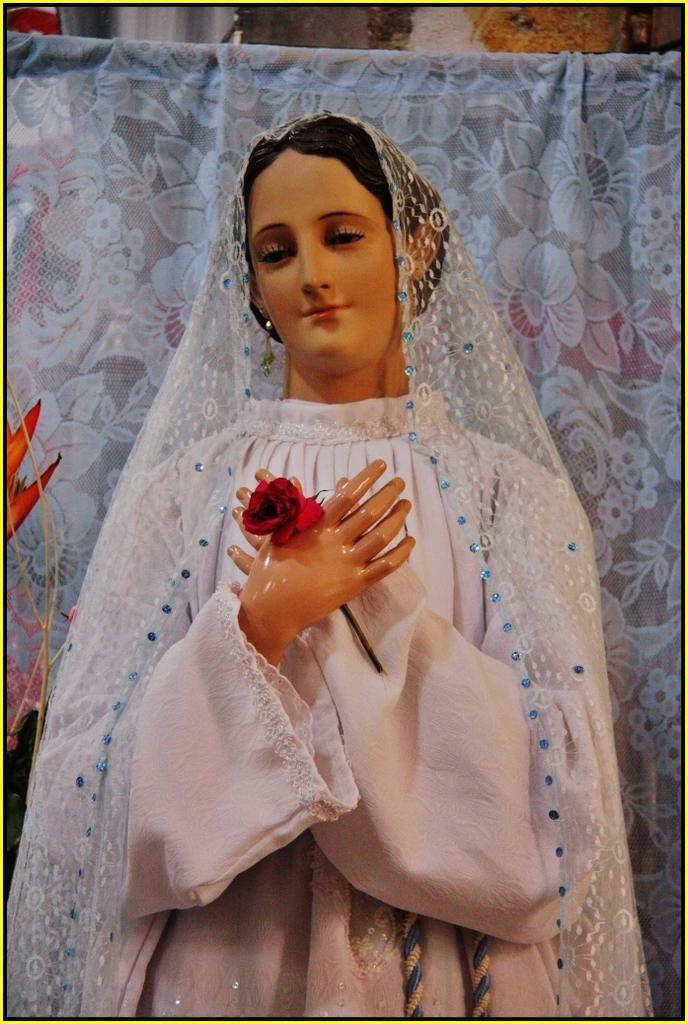What is the main subject of the image? There is a statue of a woman in the image. What is the woman holding in the image? The woman is holding a flower. What can be seen behind the statue in the image? There is a curtain visible behind the statue. What type of fire can be seen burning behind the statue in the image? There is no fire present in the image; it features a statue of a woman holding a flower with a curtain behind it. 